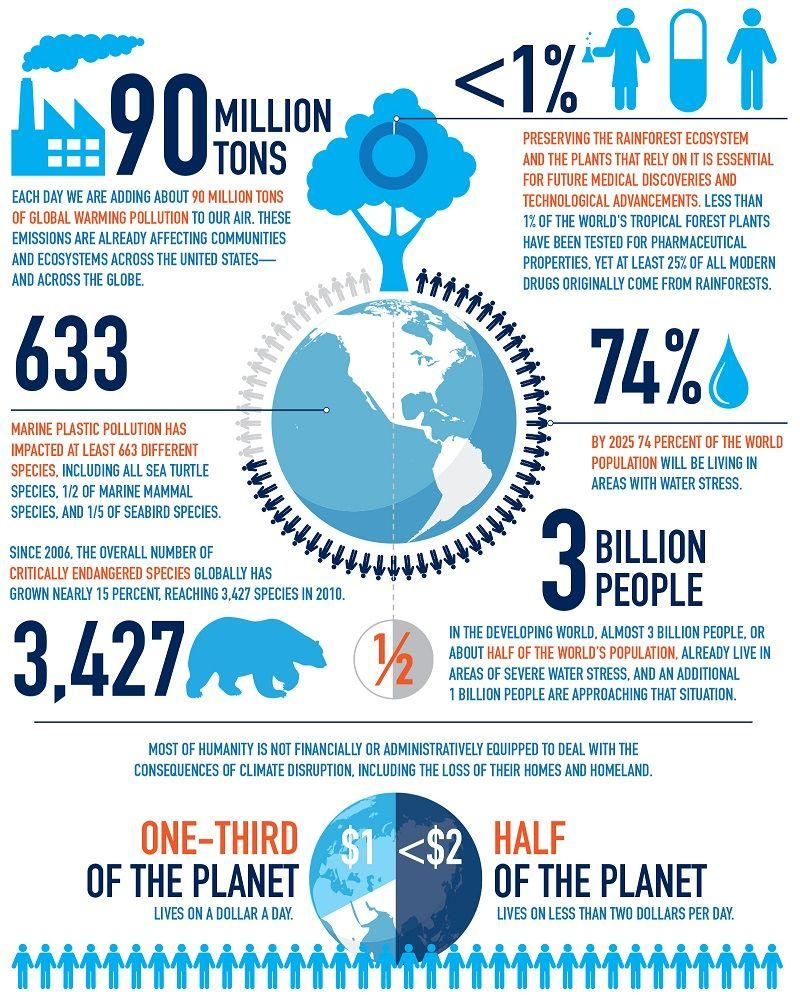List a handful of essential elements in this visual. It is estimated that 33.33% of people around the world earn only $1 per day. According to estimates, approximately 50% of people across the globe earn less than $2 per day. 